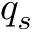Convert formula to latex. <formula><loc_0><loc_0><loc_500><loc_500>q _ { s }</formula> 